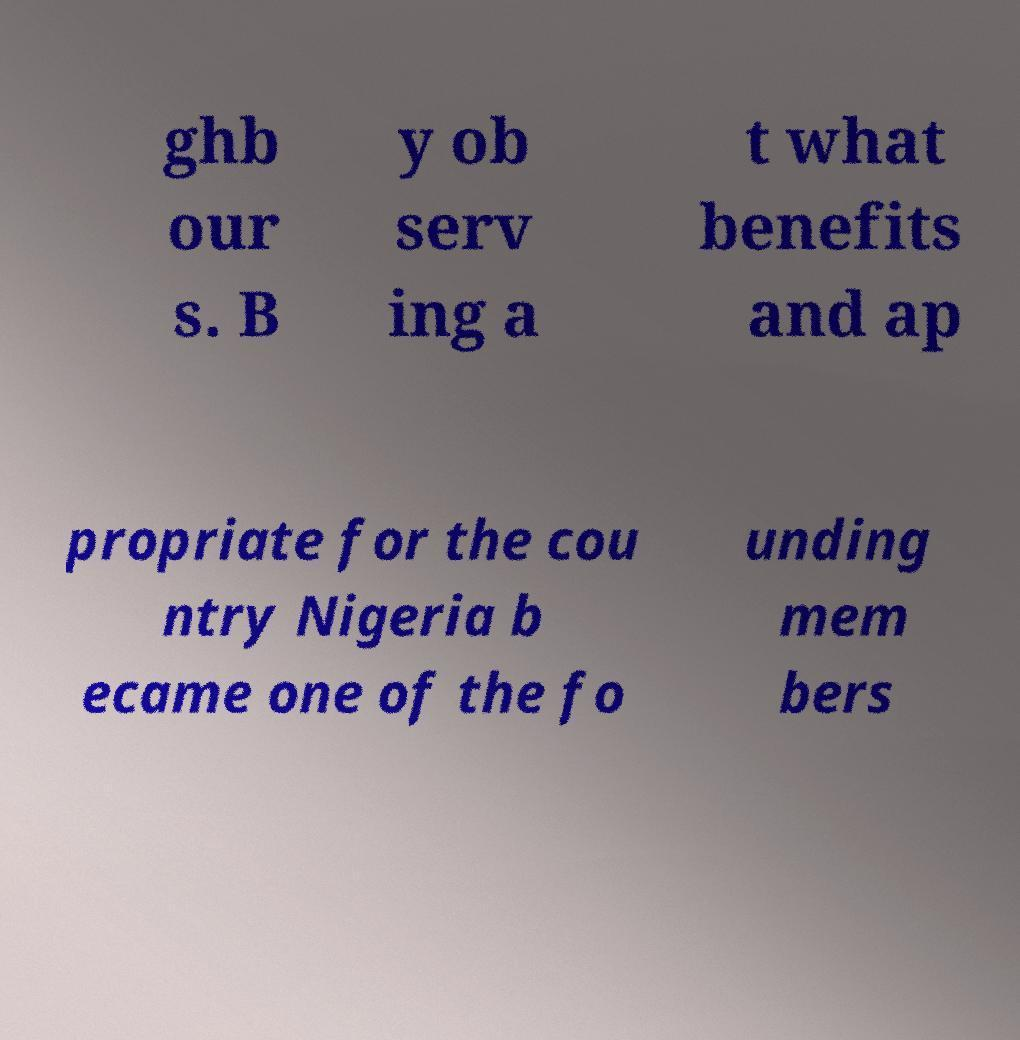Can you read and provide the text displayed in the image?This photo seems to have some interesting text. Can you extract and type it out for me? ghb our s. B y ob serv ing a t what benefits and ap propriate for the cou ntry Nigeria b ecame one of the fo unding mem bers 